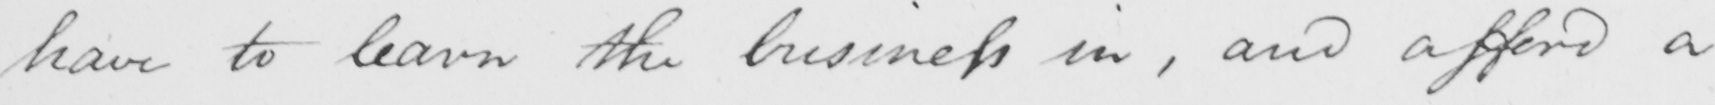What is written in this line of handwriting? have to learn the business in , and afford a 